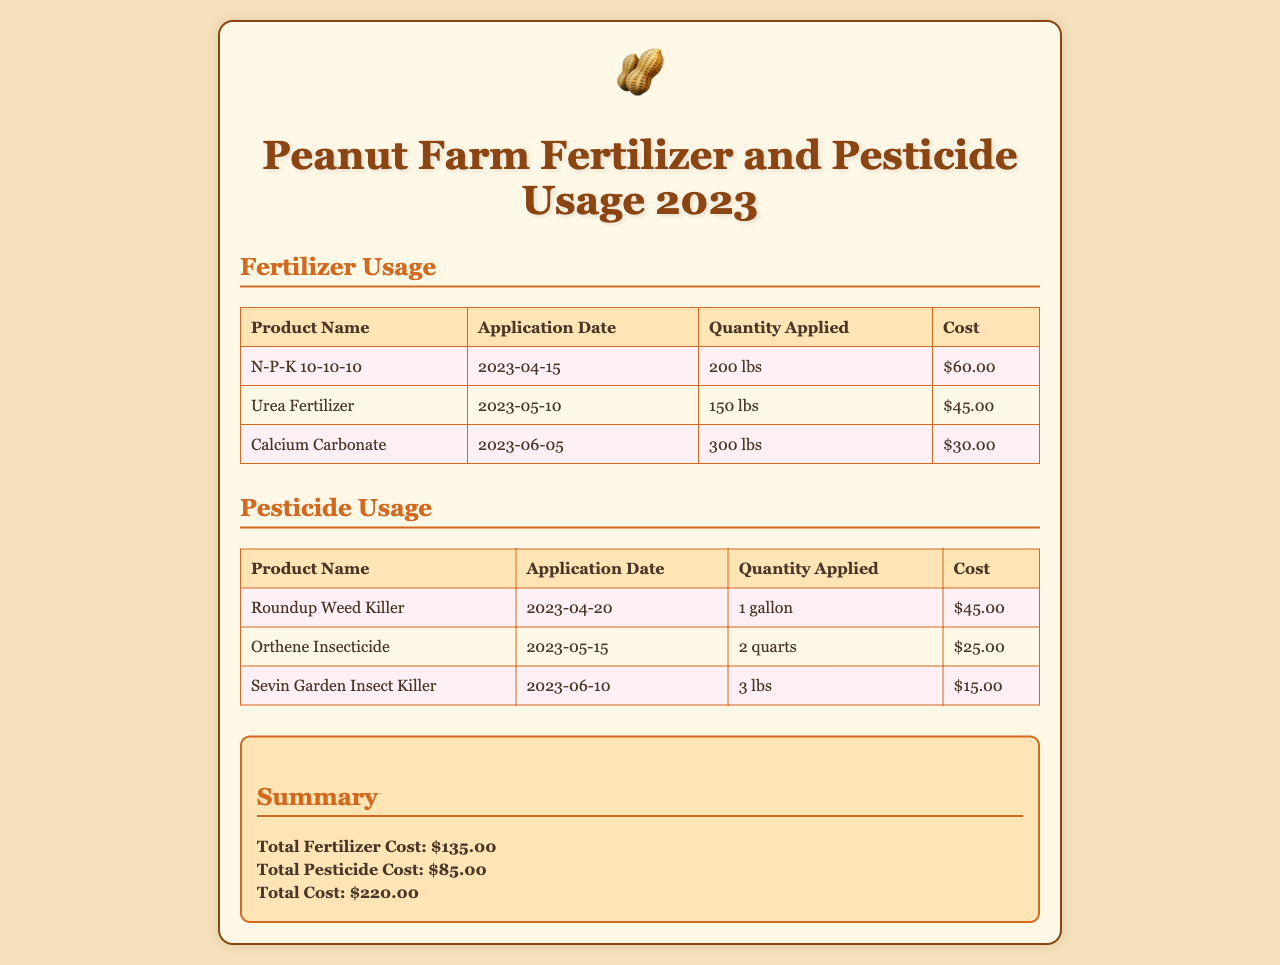What is the application date for N-P-K 10-10-10? The application date for N-P-K 10-10-10 is provided in the Fertilizer Usage section of the document.
Answer: 2023-04-15 What is the quantity of Urea Fertilizer applied? The quantity of Urea Fertilizer is listed in the Fertilizer Usage table.
Answer: 150 lbs What is the cost of Sevin Garden Insect Killer? The cost of Sevin Garden Insect Killer can be found in the Pesticide Usage section of the document.
Answer: $15.00 What is the total fertilizer cost? The total fertilizer cost is calculated from the sum of all individual fertilizer costs listed in the summary section.
Answer: $135.00 How many pounds of Calcium Carbonate were applied? The quantity of Calcium Carbonate is specified in the Fertilizer Usage table.
Answer: 300 lbs What is the total pesticide cost? The total pesticide cost is mentioned in the summary section, combining all pesticide expenses.
Answer: $85.00 What was the application date for Orthene Insecticide? The application date for Orthene Insecticide is included in the Pesticide Usage section.
Answer: 2023-05-15 What is the total cost of fertilizer and pesticide combined? The total cost is the sum of total fertilizer and pesticide costs, provided in the summary.
Answer: $220.00 How much Roundup Weed Killer was applied? The quantity of Roundup Weed Killer is recorded in the Pesticide Usage table.
Answer: 1 gallon 